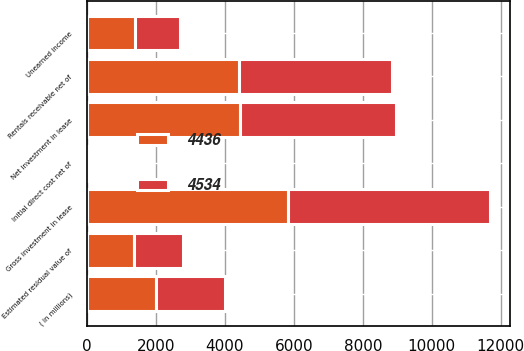Convert chart. <chart><loc_0><loc_0><loc_500><loc_500><stacked_bar_chart><ecel><fcel>( in millions)<fcel>Rentals receivable net of<fcel>Estimated residual value of<fcel>Initial direct cost net of<fcel>Gross investment in lease<fcel>Unearned income<fcel>Net investment in lease<nl><fcel>4436<fcel>2008<fcel>4415<fcel>1381<fcel>24<fcel>5820<fcel>1384<fcel>4436<nl><fcel>4534<fcel>2007<fcel>4438<fcel>1397<fcel>24<fcel>5859<fcel>1325<fcel>4534<nl></chart> 